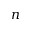<formula> <loc_0><loc_0><loc_500><loc_500>n</formula> 